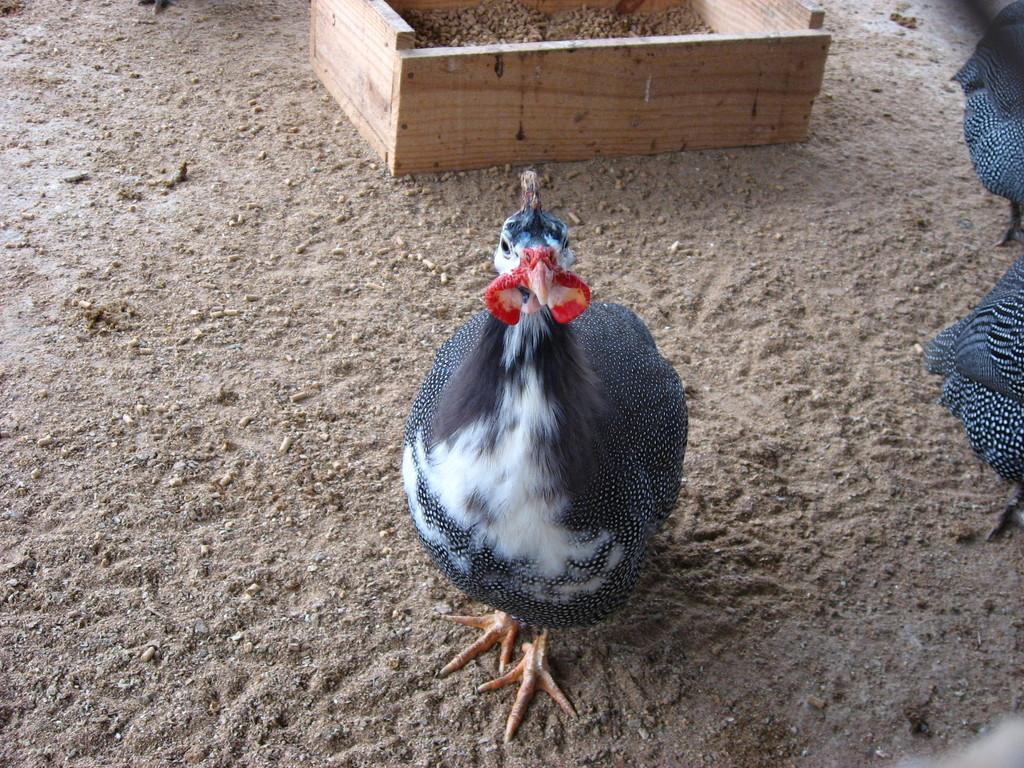What type of animal is present in the image? There is a bird in the image. What color is the bird in the image? The bird is in black and white color. What type of terrain is visible in the image? There is sand in the image. What object can be seen at the top of the image? There is a wooden box at the top of the image. What type of yoke is the bird carrying in the image? There is no yoke present in the image, and the bird is not carrying anything. 